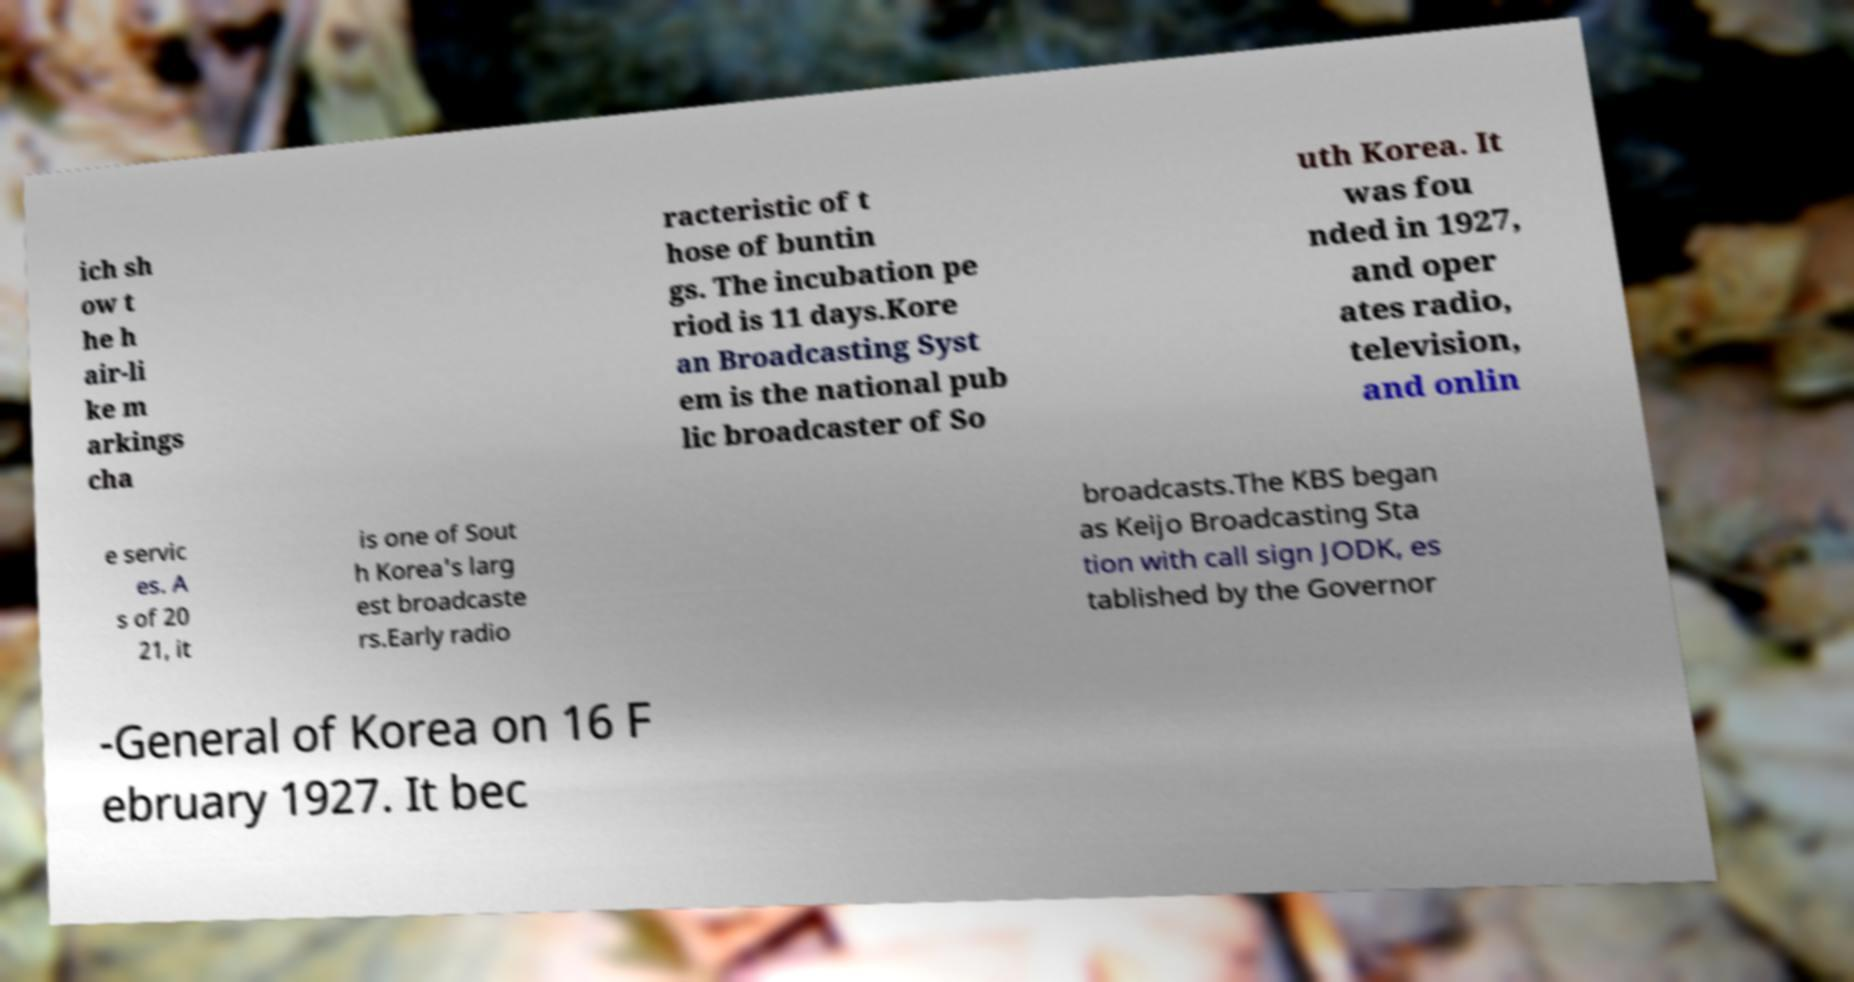Could you extract and type out the text from this image? ich sh ow t he h air-li ke m arkings cha racteristic of t hose of buntin gs. The incubation pe riod is 11 days.Kore an Broadcasting Syst em is the national pub lic broadcaster of So uth Korea. It was fou nded in 1927, and oper ates radio, television, and onlin e servic es. A s of 20 21, it is one of Sout h Korea's larg est broadcaste rs.Early radio broadcasts.The KBS began as Keijo Broadcasting Sta tion with call sign JODK, es tablished by the Governor -General of Korea on 16 F ebruary 1927. It bec 